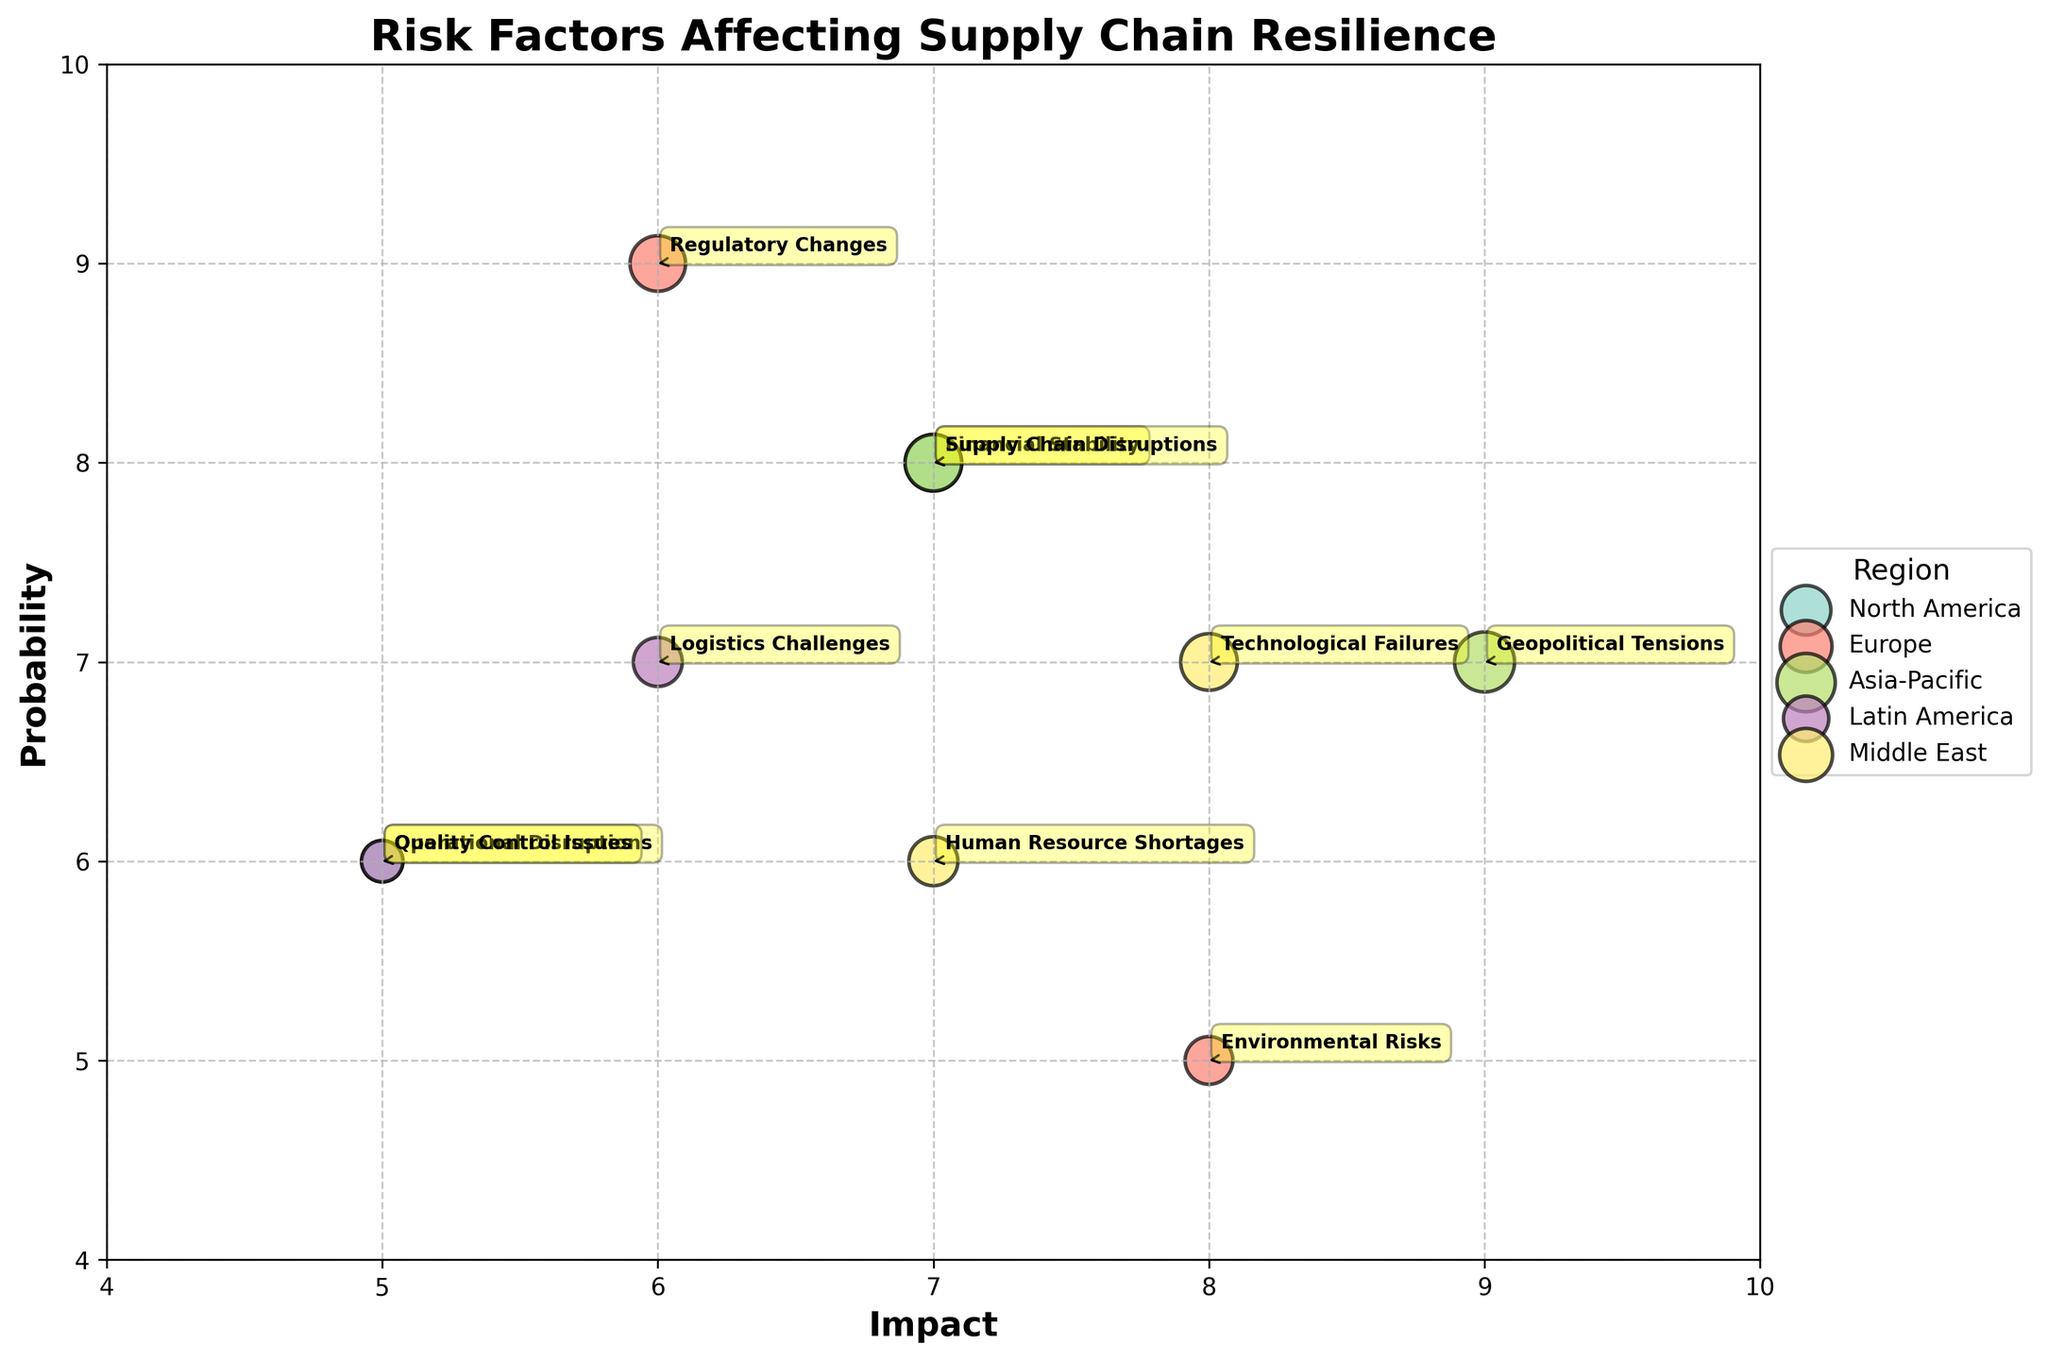What is the title of the figure? The title is located at the top of the chart and provides an overview of the primary focus of the figure. The title of the figure is "Risk Factors Affecting Supply Chain Resilience."
Answer: Risk Factors Affecting Supply Chain Resilience Which region has the most significant impact on supply chain resilience? To determine which region has the most significant impact, look for the region with the highest impact value among all data points. The highest impact value is 9, which corresponds to Geopolitical Tensions in the Asia-Pacific region.
Answer: Asia-Pacific How many risk factors are identified in North America? Count the number of bubbles (data points) that are labeled with North America as the region. In the figure, North America has two risk factors: Financial Stability (Deloitte) and Operational Disruptions (Accenture).
Answer: 2 Which risk factor has the highest probability in Europe? Identify the labels associated with Europe and compare their probability values. In Europe, Regulatory Changes (KPMG) has a probability of 9, which is the highest compared to Environmental Risks (PwC) with a probability of 5.
Answer: Regulatory Changes What is the bubble size for the risk factor "Logistics Challenges" in Latin America? Locate the bubble corresponding to "Logistics Challenges" in Latin America and refer to its bubble size. The bubble size for Logistics Challenges (Softtek) in Latin America is 42.
Answer: 42 Which supplier in the Middle East is associated with Human Resource Shortages? Find the label with "Human Resource Shortages" and check the supplier name in the same row for the Middle East. The supplier associated with Human Resource Shortages in the Middle East is BDO.
Answer: BDO Is the impact of Environmental Risks in Europe greater than that of Operational Disruptions in North America? Compare the impact values of Environmental Risks in Europe (8) and Operational Disruptions in North America (5). Since 8 is greater than 5, Environmental Risks has a greater impact.
Answer: Yes Which risk factor has a bubble size of 56 in North America? Identify all bubbles with a bubble size of 56 and check their respective regions to find the one belonging to North America. The risk factor with a bubble size of 56 in North America is Financial Stability (Deloitte).
Answer: Financial Stability How does the probability of Technological Failures in the Middle East compare to that of Geopolitical Tensions in Asia-Pacific? Technological Failures in the Middle East has a probability of 7. Geopolitical Tensions in Asia-Pacific has a probability of 7. Comparing both values, they are equal.
Answer: Equal 